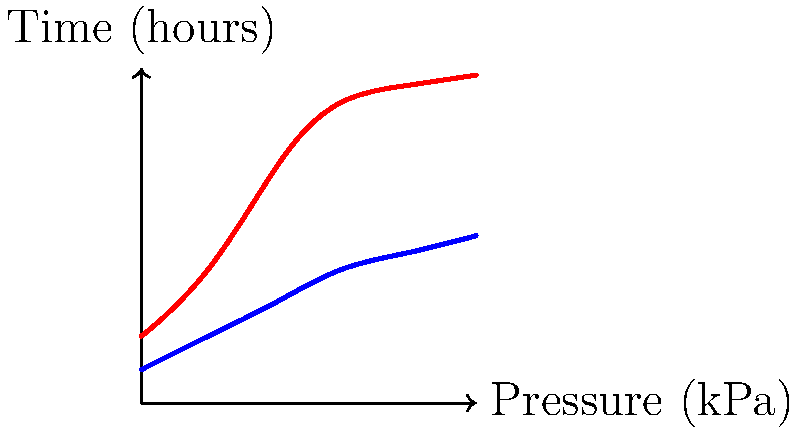Based on the pressure map shown, which type of footwear would you recommend to the art dealer for extended gallery visits to minimize foot fatigue and potential biomechanical issues? To answer this question, we need to analyze the pressure map and understand its implications:

1. The graph shows pressure (in kPa) on the y-axis and time (in hours) on the x-axis for two types of footwear: dress shoes and sneakers.

2. Dress shoes (red curve):
   - Start at a higher initial pressure (about 2 kPa)
   - Pressure increases rapidly over time
   - Reach a high pressure of about 9.8 kPa after 10 hours

3. Sneakers (blue curve):
   - Start at a lower initial pressure (about 1 kPa)
   - Pressure increases more gradually over time
   - Reach a much lower pressure of about 5 kPa after 10 hours

4. Biomechanical implications:
   - Higher pressure on feet can lead to increased fatigue, discomfort, and potential foot problems
   - Lower pressure distribution is generally better for long periods of standing or walking

5. Considering the art dealer's need for extended gallery visits:
   - Lower pressure over time is preferable to reduce foot fatigue and potential biomechanical issues
   - Sneakers provide significantly lower pressure throughout the day compared to dress shoes

6. Professional appearance:
   - While dress shoes might be considered more formal, the health and comfort of the art dealer should be prioritized for long gallery visits

Therefore, based on the pressure map and biomechanical considerations, sneakers would be the recommended footwear for the art dealer during extended gallery visits.
Answer: Sneakers 